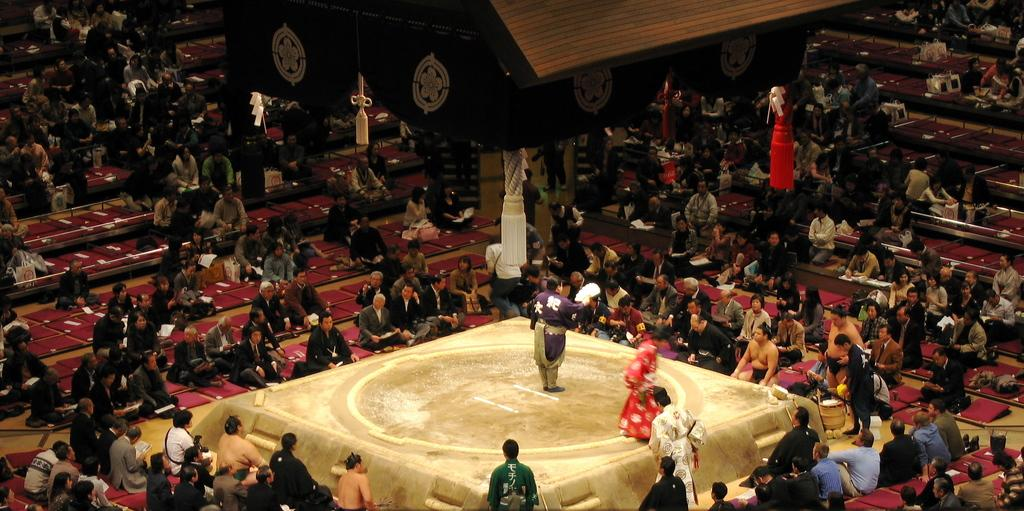What are the people in the image doing? There are many people sitting on the ground in the image. What is the central feature in the middle of the image? There is a dais in the middle of the image. How many people are on the dais? Two persons are on the dais. What structure can be seen at the top of the image? There is a tent visible at the top of the image. What type of vein is visible on the dais in the image? There are no veins visible in the image; the dais is a platform or stage. What are the people learning in the image? The image does not show any learning activity; it only shows people sitting and a dais with two persons on it. 